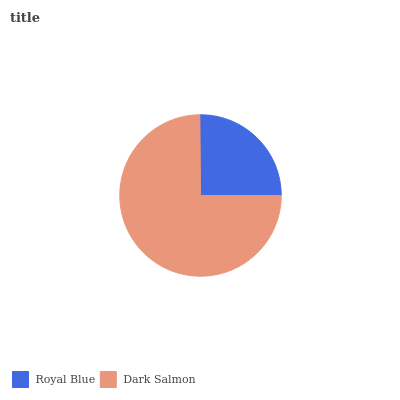Is Royal Blue the minimum?
Answer yes or no. Yes. Is Dark Salmon the maximum?
Answer yes or no. Yes. Is Dark Salmon the minimum?
Answer yes or no. No. Is Dark Salmon greater than Royal Blue?
Answer yes or no. Yes. Is Royal Blue less than Dark Salmon?
Answer yes or no. Yes. Is Royal Blue greater than Dark Salmon?
Answer yes or no. No. Is Dark Salmon less than Royal Blue?
Answer yes or no. No. Is Dark Salmon the high median?
Answer yes or no. Yes. Is Royal Blue the low median?
Answer yes or no. Yes. Is Royal Blue the high median?
Answer yes or no. No. Is Dark Salmon the low median?
Answer yes or no. No. 